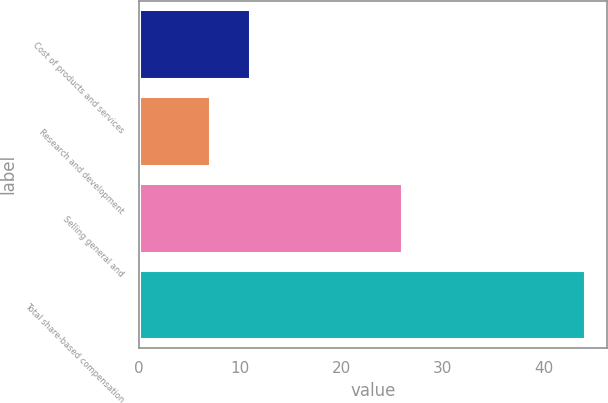Convert chart. <chart><loc_0><loc_0><loc_500><loc_500><bar_chart><fcel>Cost of products and services<fcel>Research and development<fcel>Selling general and<fcel>Total share-based compensation<nl><fcel>11<fcel>7<fcel>26<fcel>44<nl></chart> 